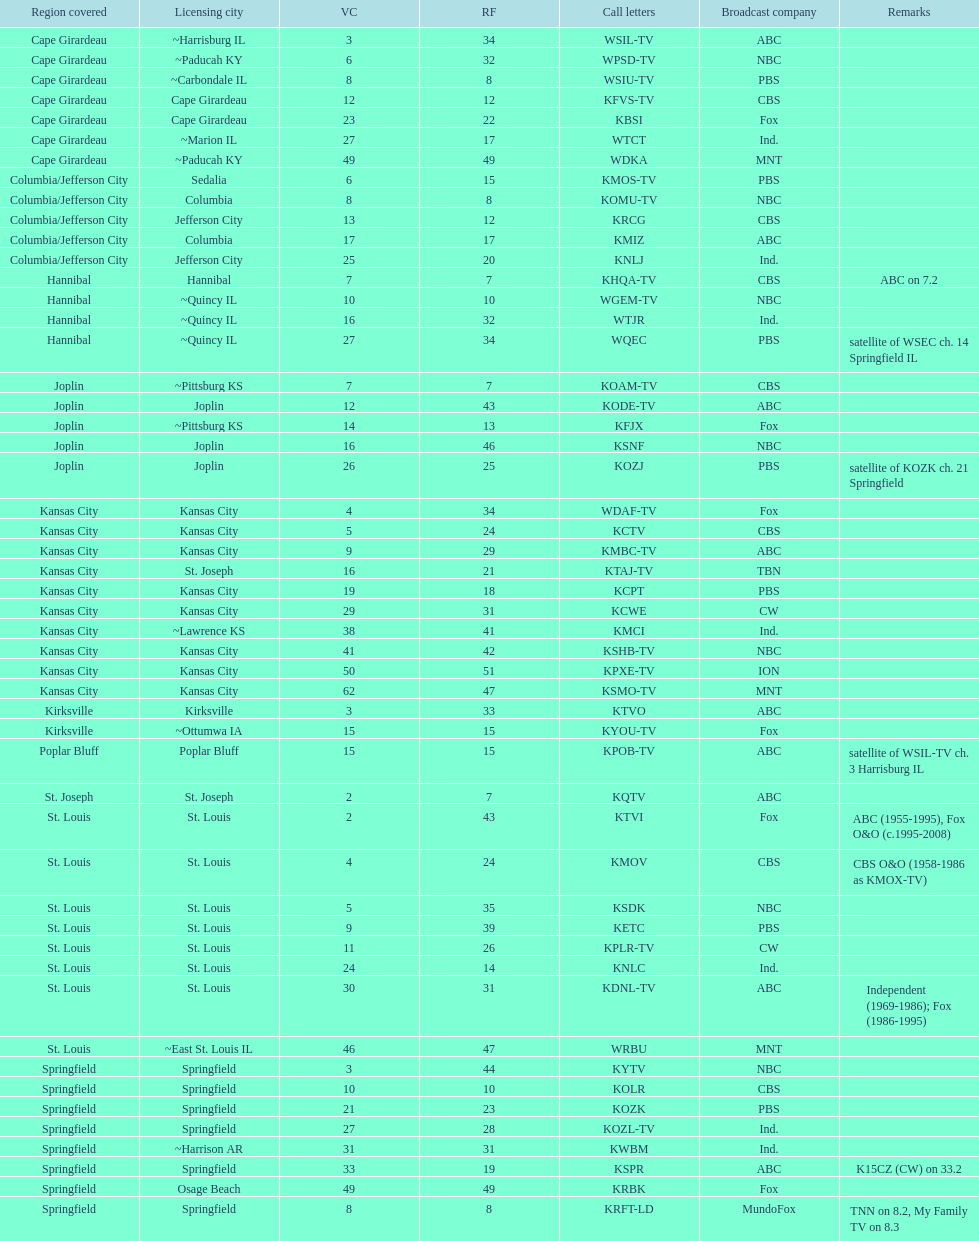Which station is licensed in the same city as koam-tv? KFJX. 